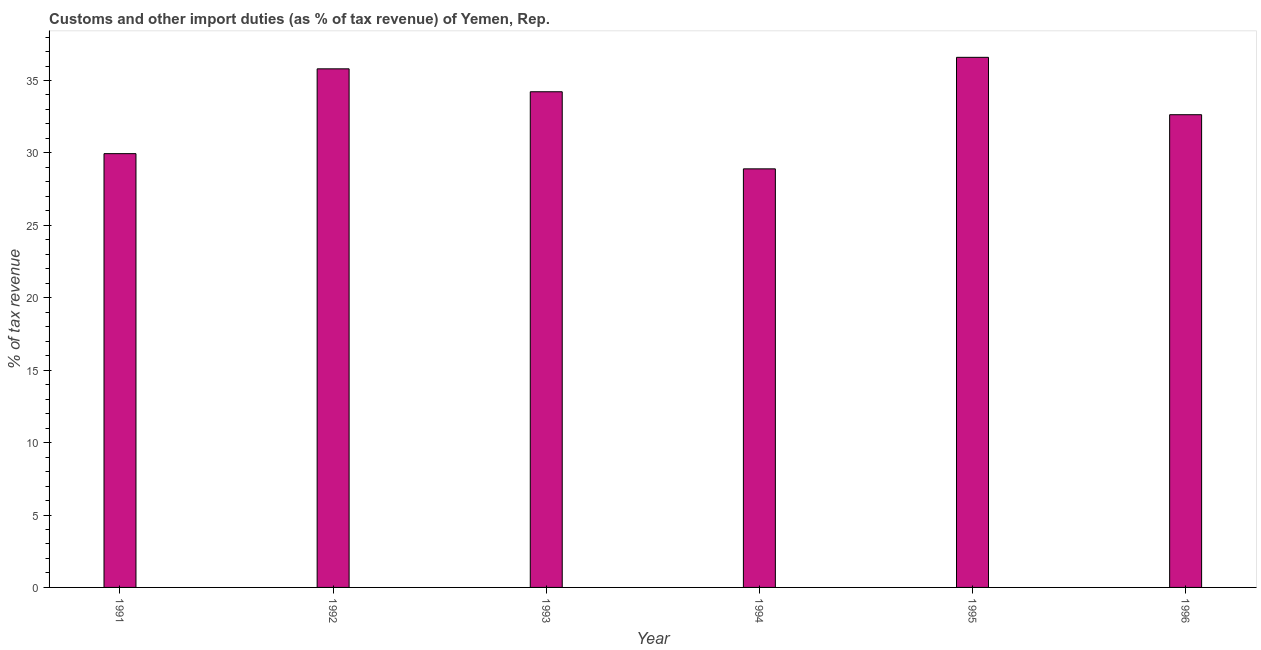Does the graph contain grids?
Ensure brevity in your answer.  No. What is the title of the graph?
Your answer should be compact. Customs and other import duties (as % of tax revenue) of Yemen, Rep. What is the label or title of the X-axis?
Provide a short and direct response. Year. What is the label or title of the Y-axis?
Your answer should be very brief. % of tax revenue. What is the customs and other import duties in 1992?
Offer a very short reply. 35.81. Across all years, what is the maximum customs and other import duties?
Offer a very short reply. 36.6. Across all years, what is the minimum customs and other import duties?
Your answer should be very brief. 28.9. In which year was the customs and other import duties maximum?
Ensure brevity in your answer.  1995. What is the sum of the customs and other import duties?
Offer a terse response. 198.12. What is the difference between the customs and other import duties in 1992 and 1996?
Your answer should be very brief. 3.17. What is the average customs and other import duties per year?
Keep it short and to the point. 33.02. What is the median customs and other import duties?
Offer a terse response. 33.43. Do a majority of the years between 1991 and 1994 (inclusive) have customs and other import duties greater than 24 %?
Your answer should be compact. Yes. What is the ratio of the customs and other import duties in 1993 to that in 1996?
Ensure brevity in your answer.  1.05. Is the customs and other import duties in 1992 less than that in 1994?
Give a very brief answer. No. What is the difference between the highest and the second highest customs and other import duties?
Provide a succinct answer. 0.79. Is the sum of the customs and other import duties in 1994 and 1995 greater than the maximum customs and other import duties across all years?
Your response must be concise. Yes. How many bars are there?
Give a very brief answer. 6. What is the difference between two consecutive major ticks on the Y-axis?
Ensure brevity in your answer.  5. Are the values on the major ticks of Y-axis written in scientific E-notation?
Make the answer very short. No. What is the % of tax revenue in 1991?
Make the answer very short. 29.95. What is the % of tax revenue in 1992?
Offer a terse response. 35.81. What is the % of tax revenue in 1993?
Offer a very short reply. 34.22. What is the % of tax revenue in 1994?
Offer a terse response. 28.9. What is the % of tax revenue in 1995?
Provide a succinct answer. 36.6. What is the % of tax revenue of 1996?
Your answer should be very brief. 32.64. What is the difference between the % of tax revenue in 1991 and 1992?
Make the answer very short. -5.86. What is the difference between the % of tax revenue in 1991 and 1993?
Give a very brief answer. -4.27. What is the difference between the % of tax revenue in 1991 and 1994?
Provide a succinct answer. 1.05. What is the difference between the % of tax revenue in 1991 and 1995?
Give a very brief answer. -6.65. What is the difference between the % of tax revenue in 1991 and 1996?
Your answer should be compact. -2.69. What is the difference between the % of tax revenue in 1992 and 1993?
Provide a short and direct response. 1.58. What is the difference between the % of tax revenue in 1992 and 1994?
Your response must be concise. 6.91. What is the difference between the % of tax revenue in 1992 and 1995?
Your answer should be very brief. -0.79. What is the difference between the % of tax revenue in 1992 and 1996?
Your answer should be compact. 3.17. What is the difference between the % of tax revenue in 1993 and 1994?
Offer a terse response. 5.32. What is the difference between the % of tax revenue in 1993 and 1995?
Provide a succinct answer. -2.38. What is the difference between the % of tax revenue in 1993 and 1996?
Offer a very short reply. 1.59. What is the difference between the % of tax revenue in 1994 and 1995?
Provide a succinct answer. -7.7. What is the difference between the % of tax revenue in 1994 and 1996?
Your answer should be very brief. -3.74. What is the difference between the % of tax revenue in 1995 and 1996?
Make the answer very short. 3.96. What is the ratio of the % of tax revenue in 1991 to that in 1992?
Your answer should be very brief. 0.84. What is the ratio of the % of tax revenue in 1991 to that in 1994?
Your response must be concise. 1.04. What is the ratio of the % of tax revenue in 1991 to that in 1995?
Provide a succinct answer. 0.82. What is the ratio of the % of tax revenue in 1991 to that in 1996?
Keep it short and to the point. 0.92. What is the ratio of the % of tax revenue in 1992 to that in 1993?
Offer a very short reply. 1.05. What is the ratio of the % of tax revenue in 1992 to that in 1994?
Offer a very short reply. 1.24. What is the ratio of the % of tax revenue in 1992 to that in 1995?
Keep it short and to the point. 0.98. What is the ratio of the % of tax revenue in 1992 to that in 1996?
Provide a succinct answer. 1.1. What is the ratio of the % of tax revenue in 1993 to that in 1994?
Make the answer very short. 1.18. What is the ratio of the % of tax revenue in 1993 to that in 1995?
Provide a succinct answer. 0.94. What is the ratio of the % of tax revenue in 1993 to that in 1996?
Offer a terse response. 1.05. What is the ratio of the % of tax revenue in 1994 to that in 1995?
Ensure brevity in your answer.  0.79. What is the ratio of the % of tax revenue in 1994 to that in 1996?
Keep it short and to the point. 0.89. What is the ratio of the % of tax revenue in 1995 to that in 1996?
Offer a very short reply. 1.12. 